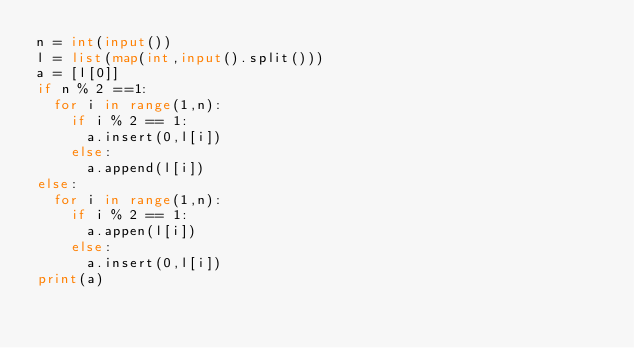<code> <loc_0><loc_0><loc_500><loc_500><_Python_>n = int(input())
l = list(map(int,input().split()))
a = [l[0]]
if n % 2 ==1:
  for i in range(1,n):
    if i % 2 == 1:
      a.insert(0,l[i])
    else:
      a.append(l[i])
else:
  for i in range(1,n):
    if i % 2 == 1:
      a.appen(l[i])
    else:
      a.insert(0,l[i])
print(a)
  </code> 